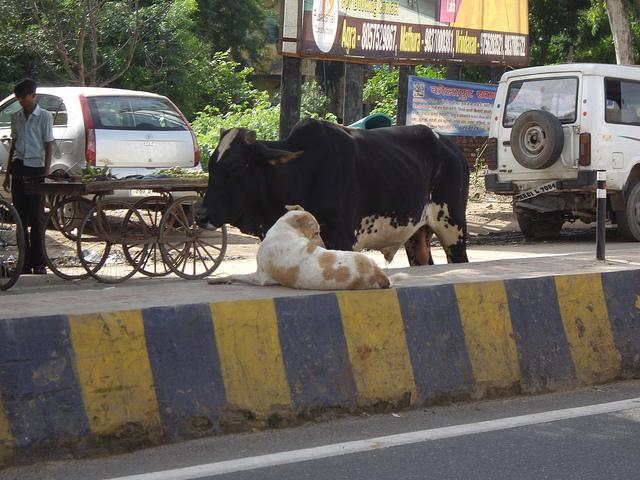What is known as the best cut of meat from the largest animal?

Choices:
A) chuck
B) sirloin
C) ribeye
D) filet mignon filet mignon 